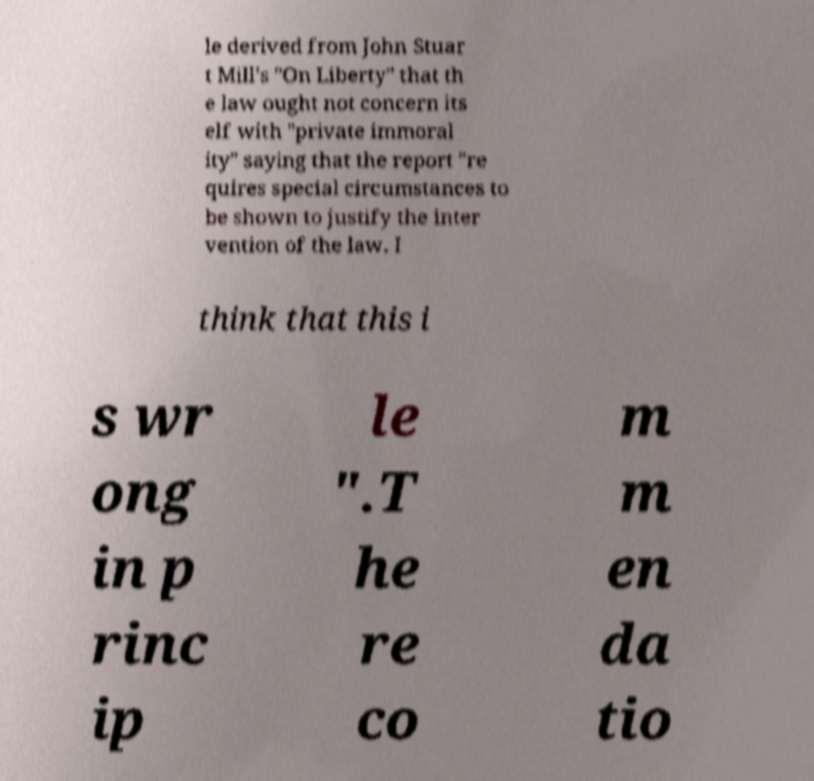Can you accurately transcribe the text from the provided image for me? le derived from John Stuar t Mill's "On Liberty" that th e law ought not concern its elf with "private immoral ity" saying that the report "re quires special circumstances to be shown to justify the inter vention of the law. I think that this i s wr ong in p rinc ip le ".T he re co m m en da tio 